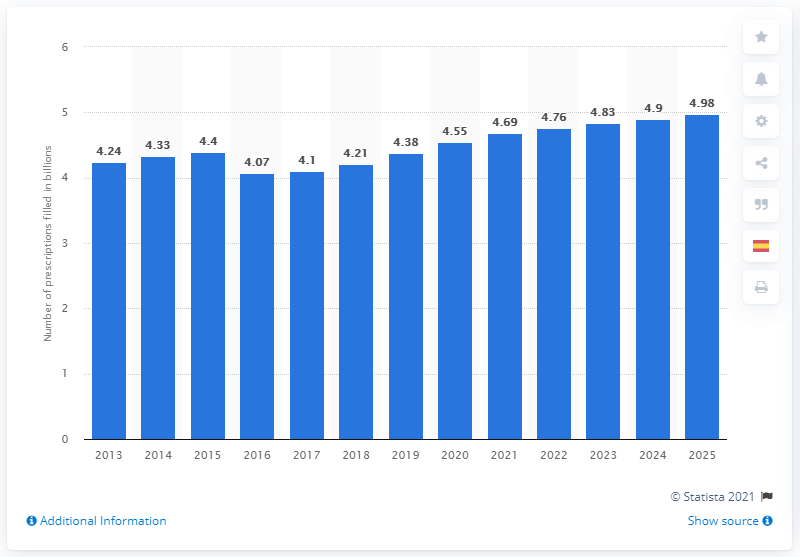Identify some key points in this picture. In 2019, it is projected that 4.38 retail prescriptions will be filled. 